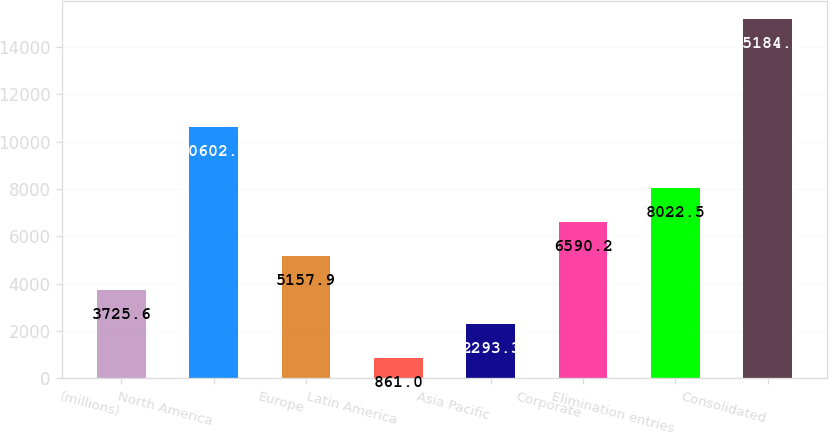<chart> <loc_0><loc_0><loc_500><loc_500><bar_chart><fcel>(millions)<fcel>North America<fcel>Europe<fcel>Latin America<fcel>Asia Pacific<fcel>Corporate<fcel>Elimination entries<fcel>Consolidated<nl><fcel>3725.6<fcel>10602<fcel>5157.9<fcel>861<fcel>2293.3<fcel>6590.2<fcel>8022.5<fcel>15184<nl></chart> 